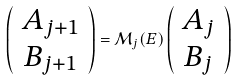Convert formula to latex. <formula><loc_0><loc_0><loc_500><loc_500>\left ( \begin{array} { c } A _ { j + 1 } \\ B _ { j + 1 } \end{array} \right ) = \mathcal { M } _ { j } ( E ) \left ( \begin{array} { c } A _ { j } \\ B _ { j } \end{array} \right )</formula> 